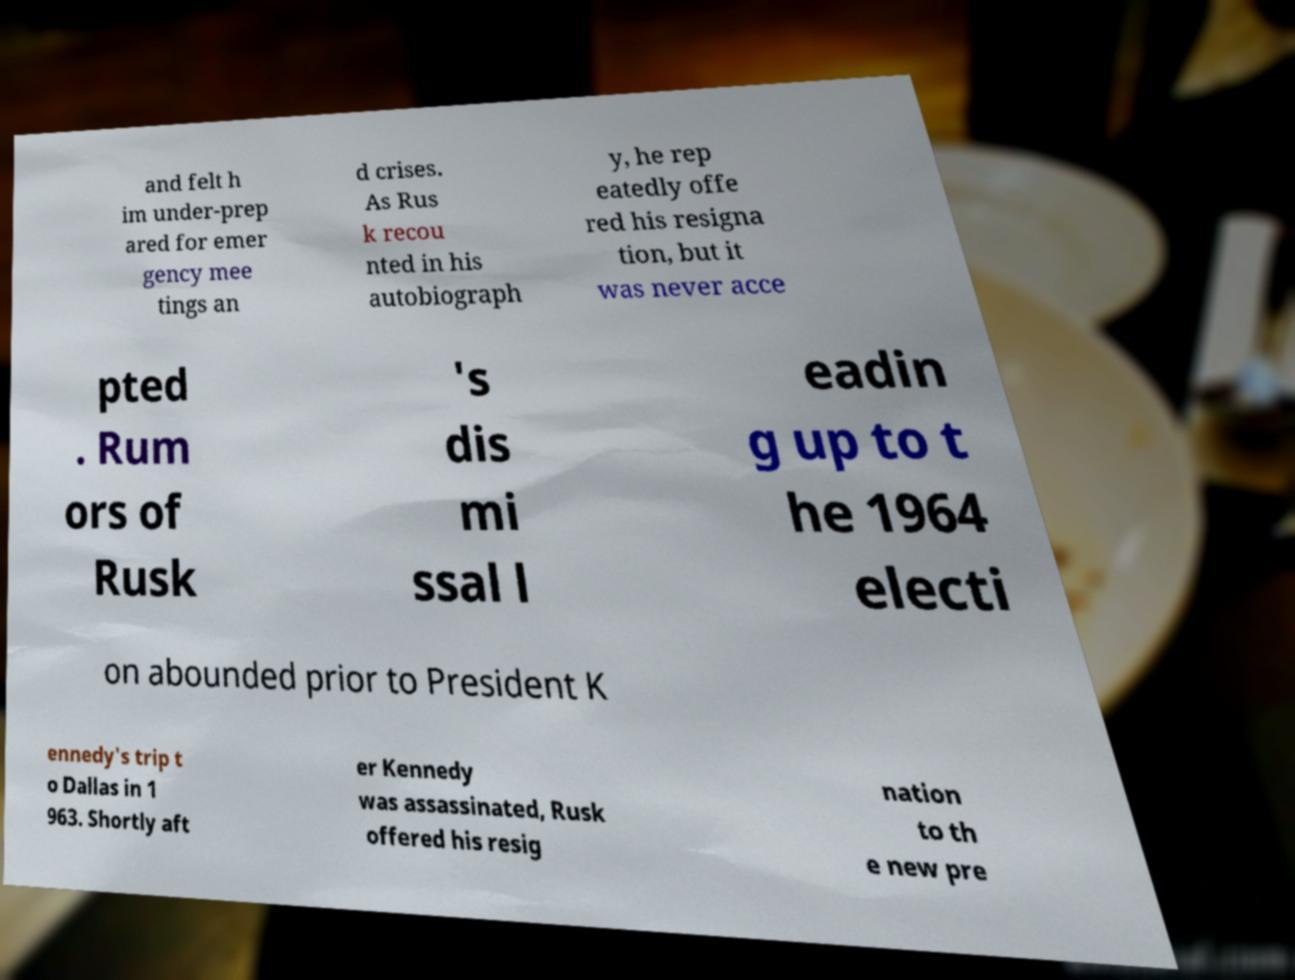Please read and relay the text visible in this image. What does it say? and felt h im under-prep ared for emer gency mee tings an d crises. As Rus k recou nted in his autobiograph y, he rep eatedly offe red his resigna tion, but it was never acce pted . Rum ors of Rusk 's dis mi ssal l eadin g up to t he 1964 electi on abounded prior to President K ennedy's trip t o Dallas in 1 963. Shortly aft er Kennedy was assassinated, Rusk offered his resig nation to th e new pre 